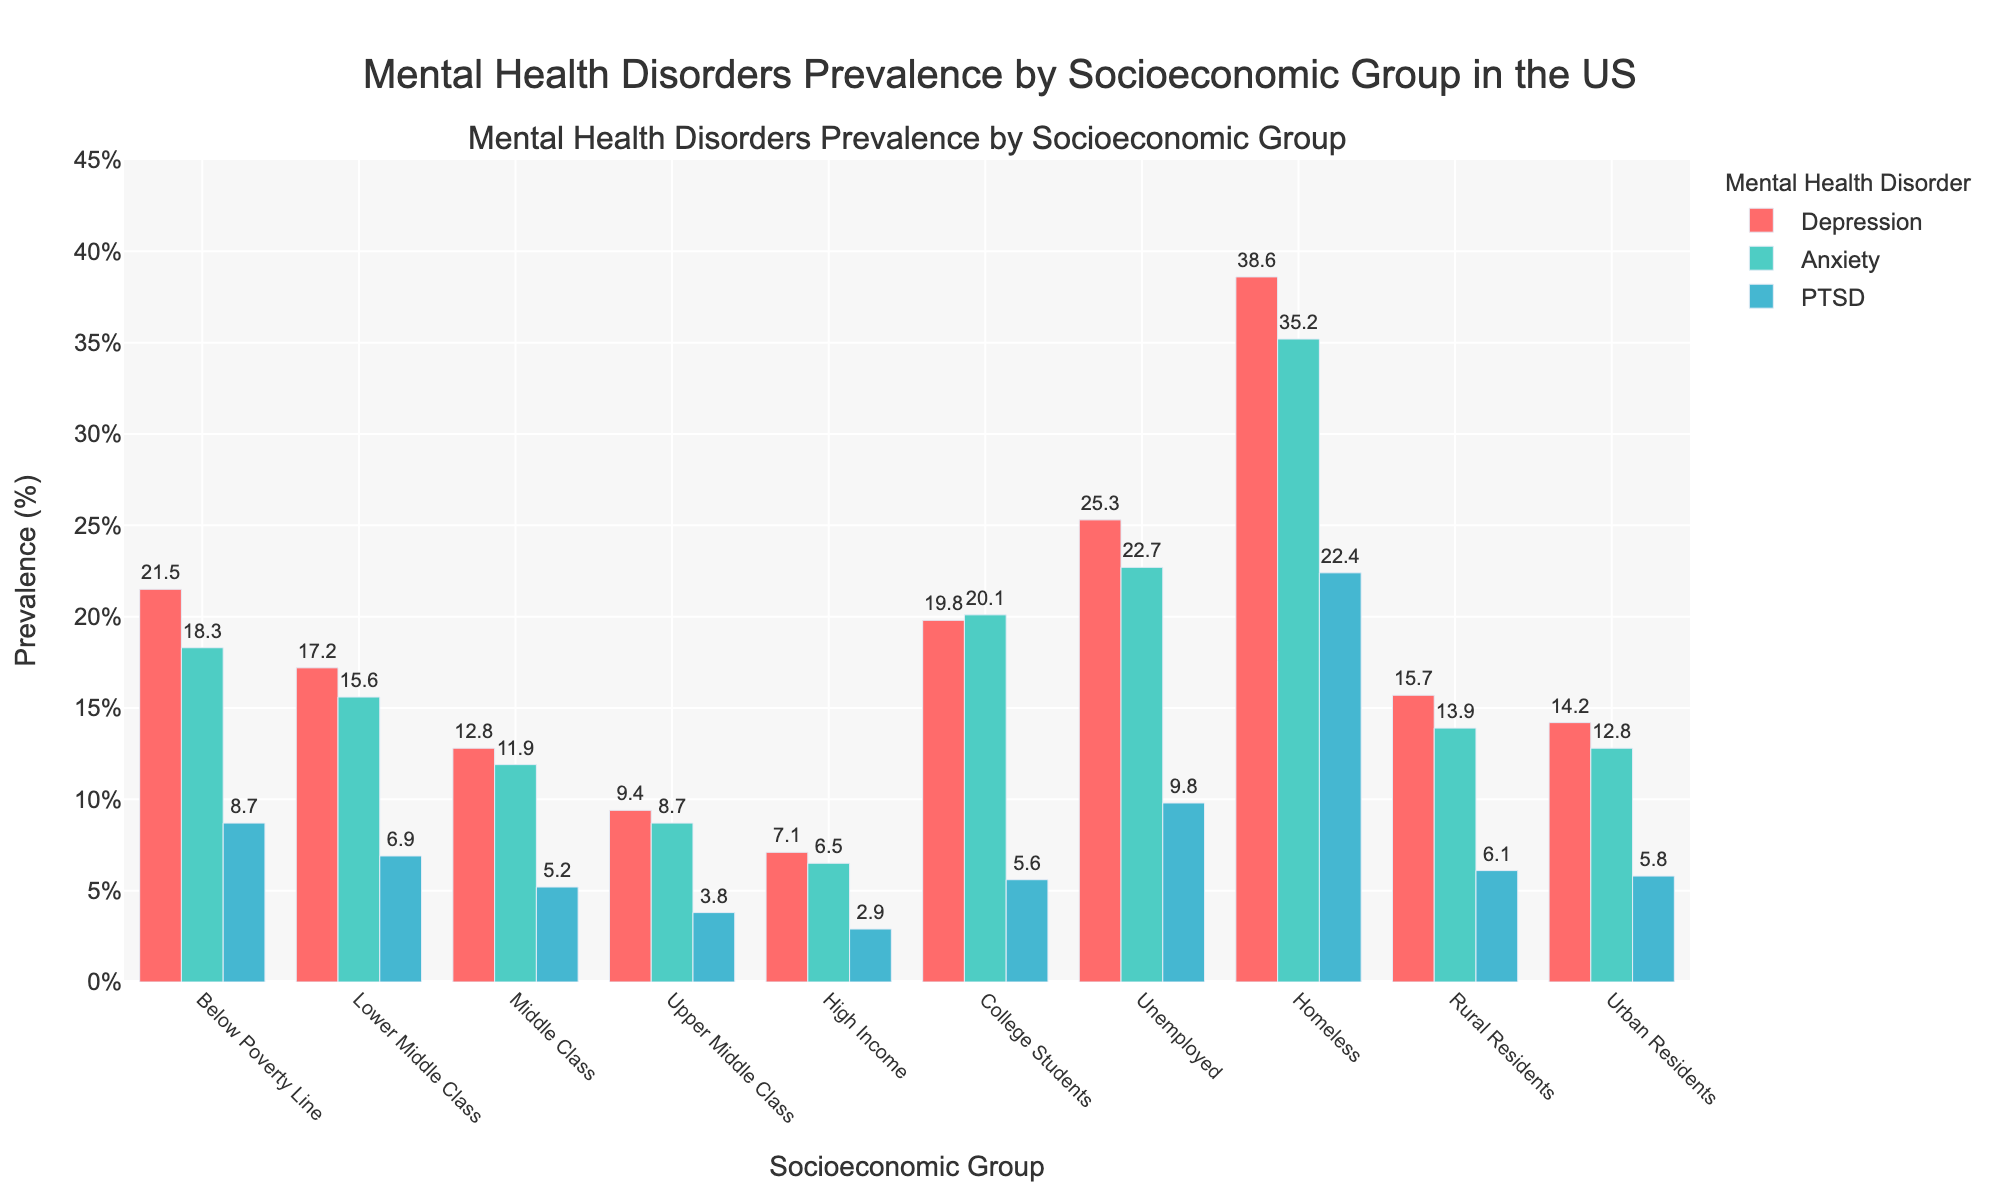Which group has the highest prevalence of PTSD? Scan the heights of the bars for PTSD (the bars in blue). The tallest bar represents the group with the highest prevalence.
Answer: Homeless Which two groups have the closest prevalence of depression? Compare the heights of the red bars for depression and find the two groups whose bar heights are closest to each other.
Answer: Lower Middle Class and Rural Residents Which group has the lowest prevalence of anxiety? Scan the heights of the green bars for anxiety. The shortest bar represents the group with the lowest prevalence.
Answer: High Income What is the difference in prevalence of anxiety between College Students and Urban Residents? Subtract the prevalence of anxiety for Urban Residents from that of College Students (20.1% - 12.8%).
Answer: 7.3% What is the combined prevalence of depression and PTSD for Below Poverty Line group? Add the prevalence of depression and PTSD for Below Poverty Line group (21.5% + 8.7%).
Answer: 30.2% Which group has a higher prevalence of depression, Middle Class or Rural Residents? Compare the heights of the red bars for Middle Class and Rural Residents (12.8% and 15.7% respectively).
Answer: Rural Residents What is the average prevalence of PTSD across all socioeconomic groups? Sum the prevalence of PTSD for all groups and divide by the number of groups. (8.7% + 6.9% + 5.2% + 3.8% + 2.9% + 5.6% + 9.8% + 22.4% + 6.1% + 5.8%) / 10.
Answer: 7.72% How much higher is the prevalence of anxiety in the Unemployed group compared to the High Income group? Subtract the prevalence of anxiety for High Income group from that of the Unemployed group (22.7% - 6.5%).
Answer: 16.2% What is the ratio of prevalence of depression in Homeless to that in High Income group? Divide the prevalence of depression in Homeless group by that in High Income group (38.6% / 7.1%).
Answer: Approximately 5.4 Which group shows the largest visual difference between prevalence of depression and anxiety? For each group, find the difference between the heights of the red and green bars. Identify the group with the largest difference.
Answer: College Students 